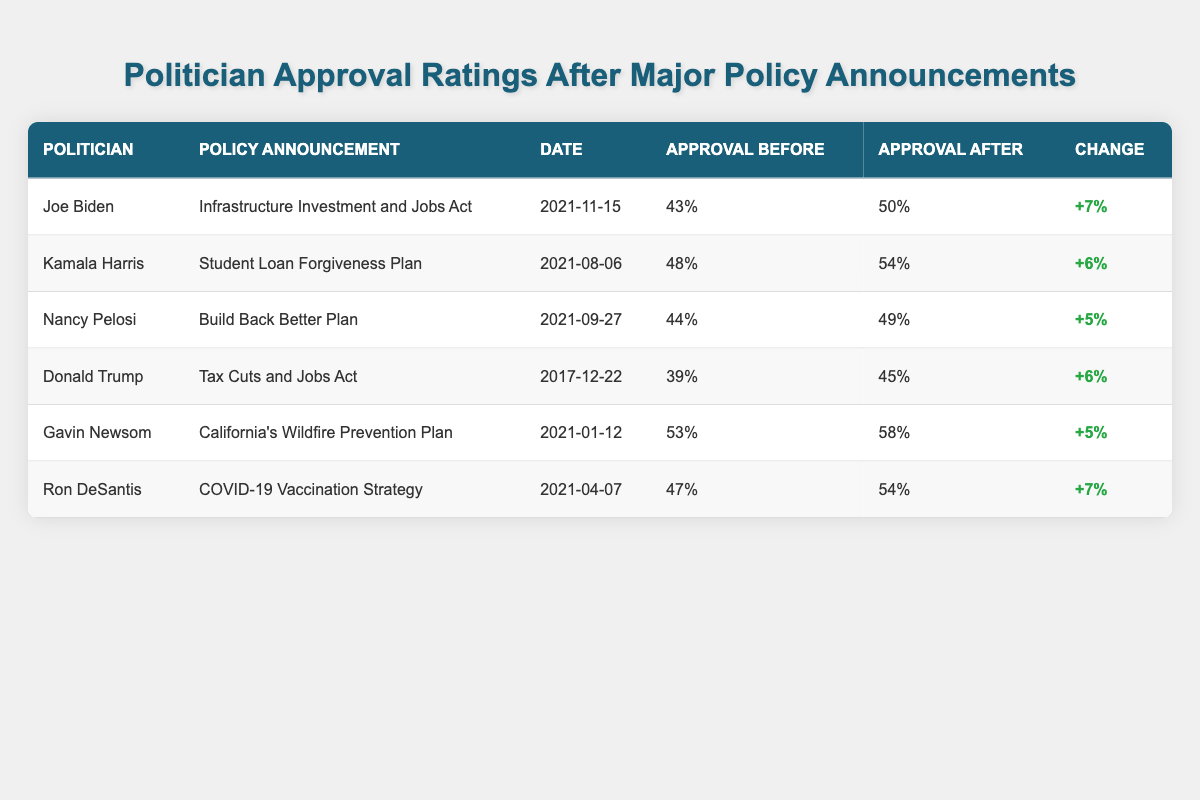What was Joe Biden's approval rating before the Infrastructure Investment and Jobs Act? According to the table, Joe Biden's approval rating before the announcement was 43%.
Answer: 43% What is the change in approval rating for Kamala Harris after the Student Loan Forgiveness Plan? The table shows that Kamala Harris's approval rating increased from 48% to 54%, resulting in a change of +6%.
Answer: +6% Who had the highest approval rating before their policy announcement? By inspecting the table, Gavin Newsom had the highest approval rating before his announcement at 53%.
Answer: 53% What was the average change in approval ratings for all politicians listed? To find the average change, we need to sum the changes: (+7 + 6 + 5 + 6 + 5 + 7) = 36. Then, divide by the number of politicians (6), resulting in an average of 36/6 = 6.
Answer: 6 Did Ron DeSantis's approval rating increase after the COVID-19 Vaccination Strategy? Yes, according to the table, Ron DeSantis's approval rating increased from 47% to 54%.
Answer: Yes Which politician had the smallest increase in approval rating and what was that increase? By reviewing the table, Nancy Pelosi had the smallest increase of +5% (from 44% to 49%).
Answer: +5% 